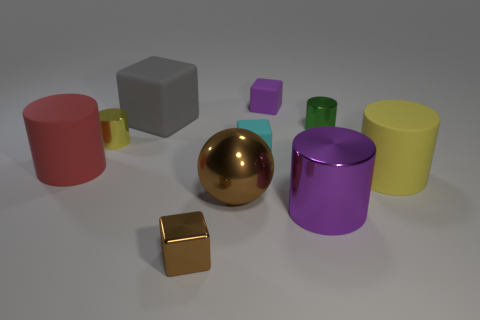Subtract 1 cylinders. How many cylinders are left? 4 Subtract all yellow blocks. Subtract all brown balls. How many blocks are left? 4 Subtract all cubes. How many objects are left? 6 Subtract all matte things. Subtract all green metallic cylinders. How many objects are left? 4 Add 3 gray rubber objects. How many gray rubber objects are left? 4 Add 7 big yellow cylinders. How many big yellow cylinders exist? 8 Subtract 0 yellow spheres. How many objects are left? 10 